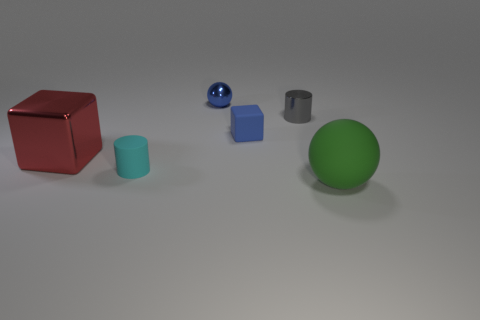Do the small sphere and the tiny rubber object behind the cyan thing have the same color?
Your answer should be compact. Yes. There is a blue thing on the right side of the shiny object that is behind the small object that is to the right of the matte cube; what is it made of?
Offer a terse response. Rubber. Do the tiny cyan rubber object and the blue object behind the gray metallic cylinder have the same shape?
Your answer should be compact. No. What number of blue matte things have the same shape as the red metal object?
Provide a short and direct response. 1. There is a red metallic object; what shape is it?
Provide a succinct answer. Cube. What size is the cylinder that is on the right side of the ball that is behind the green matte sphere?
Ensure brevity in your answer.  Small. What number of objects are either tiny yellow objects or matte objects?
Your response must be concise. 3. Do the gray thing and the big green rubber thing have the same shape?
Ensure brevity in your answer.  No. Is there a tiny thing made of the same material as the small cyan cylinder?
Provide a short and direct response. Yes. Are there any green matte things that are left of the small rubber object that is on the right side of the blue metallic thing?
Offer a very short reply. No. 